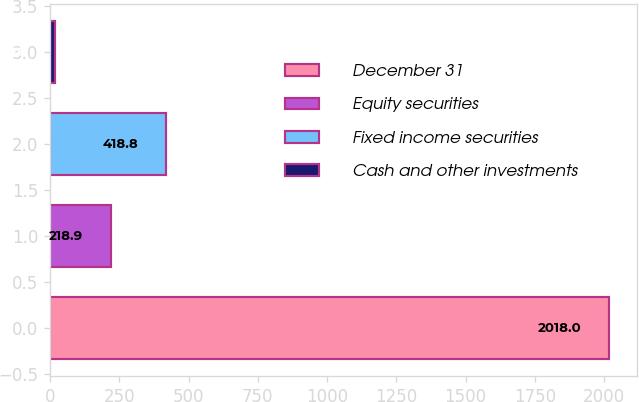Convert chart. <chart><loc_0><loc_0><loc_500><loc_500><bar_chart><fcel>December 31<fcel>Equity securities<fcel>Fixed income securities<fcel>Cash and other investments<nl><fcel>2018<fcel>218.9<fcel>418.8<fcel>19<nl></chart> 